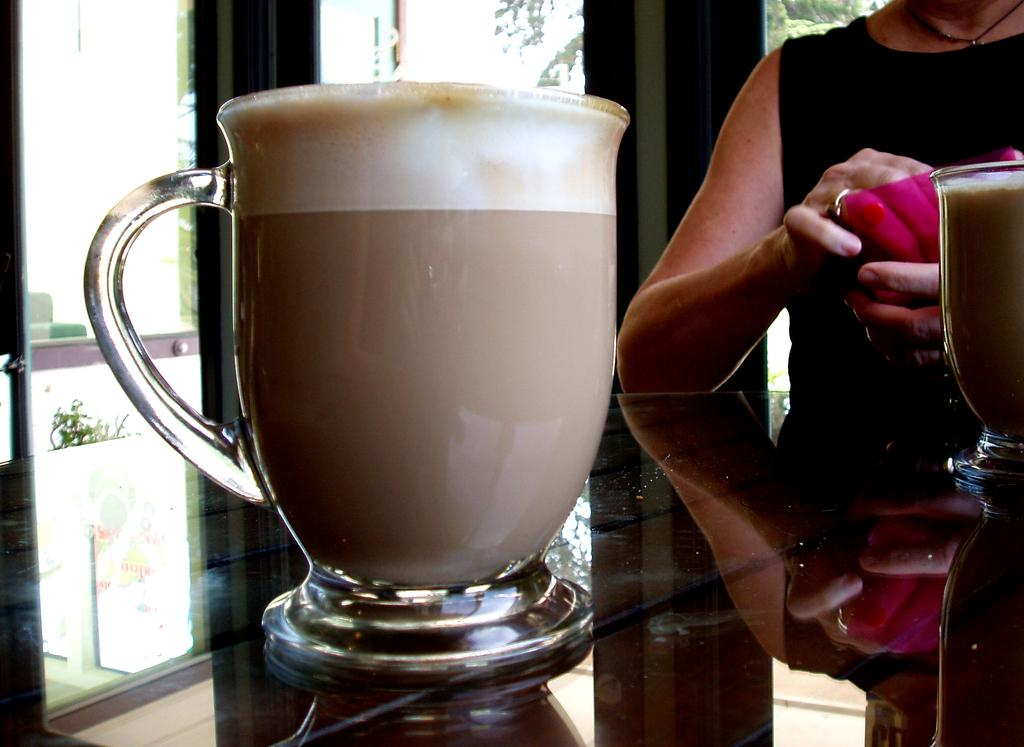What object is visible on the table in the image? There is a cup placed on a table in the image. Can you describe the woman in the image? The image contains a woman, but no specific details about her appearance or actions are provided. Where is the cup located in relation to the woman? The cup is placed on a table, but the distance or proximity to the woman is not mentioned. What type of iron is the woman using to balance the cup in the image? There is no iron or balancing act involving the cup in the image. 